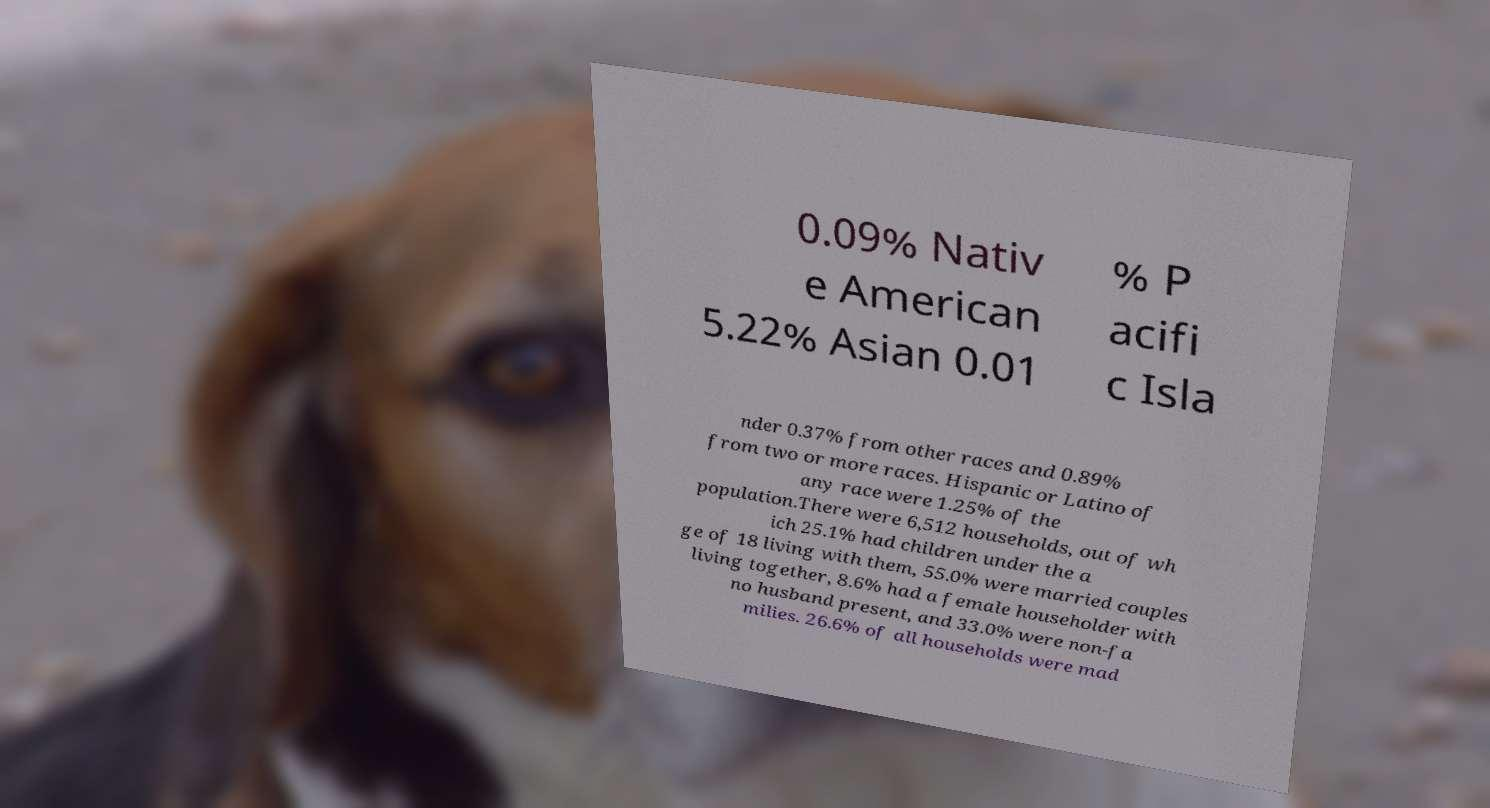Please identify and transcribe the text found in this image. 0.09% Nativ e American 5.22% Asian 0.01 % P acifi c Isla nder 0.37% from other races and 0.89% from two or more races. Hispanic or Latino of any race were 1.25% of the population.There were 6,512 households, out of wh ich 25.1% had children under the a ge of 18 living with them, 55.0% were married couples living together, 8.6% had a female householder with no husband present, and 33.0% were non-fa milies. 26.6% of all households were mad 